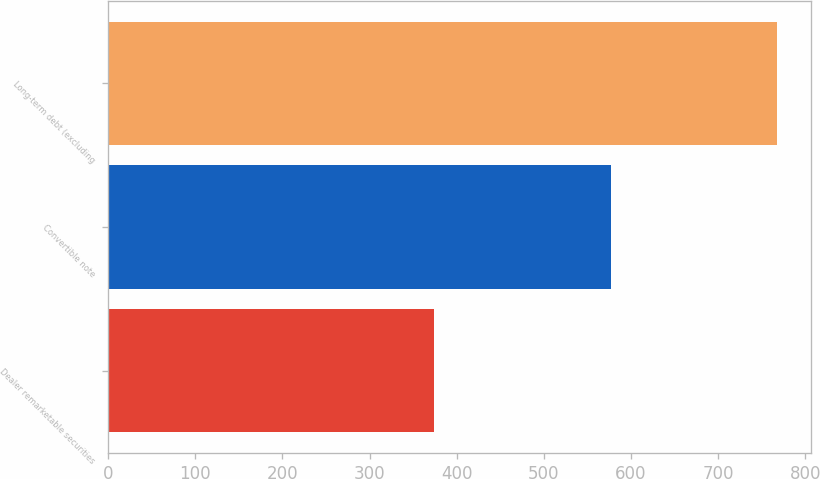<chart> <loc_0><loc_0><loc_500><loc_500><bar_chart><fcel>Dealer remarketable securities<fcel>Convertible note<fcel>Long-term debt (excluding<nl><fcel>374<fcel>577<fcel>768<nl></chart> 